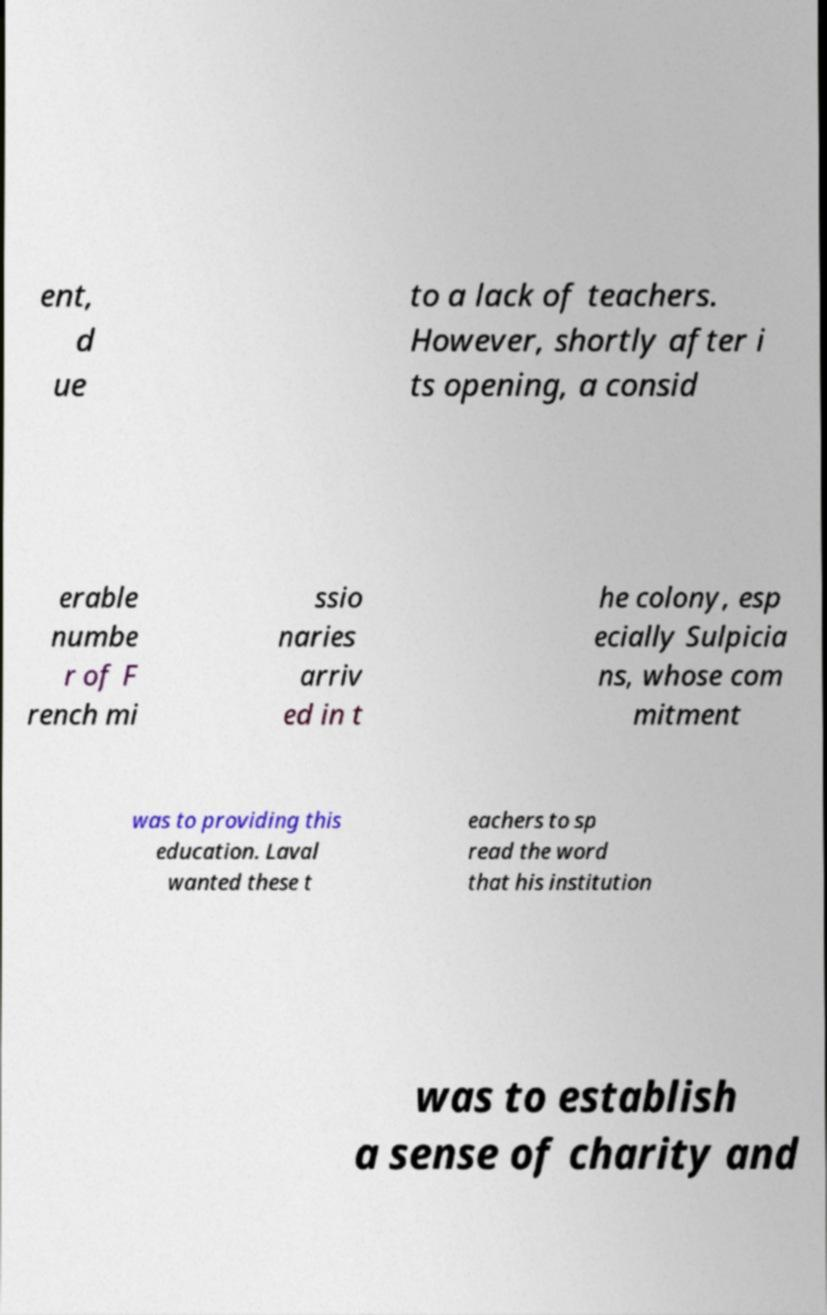There's text embedded in this image that I need extracted. Can you transcribe it verbatim? ent, d ue to a lack of teachers. However, shortly after i ts opening, a consid erable numbe r of F rench mi ssio naries arriv ed in t he colony, esp ecially Sulpicia ns, whose com mitment was to providing this education. Laval wanted these t eachers to sp read the word that his institution was to establish a sense of charity and 